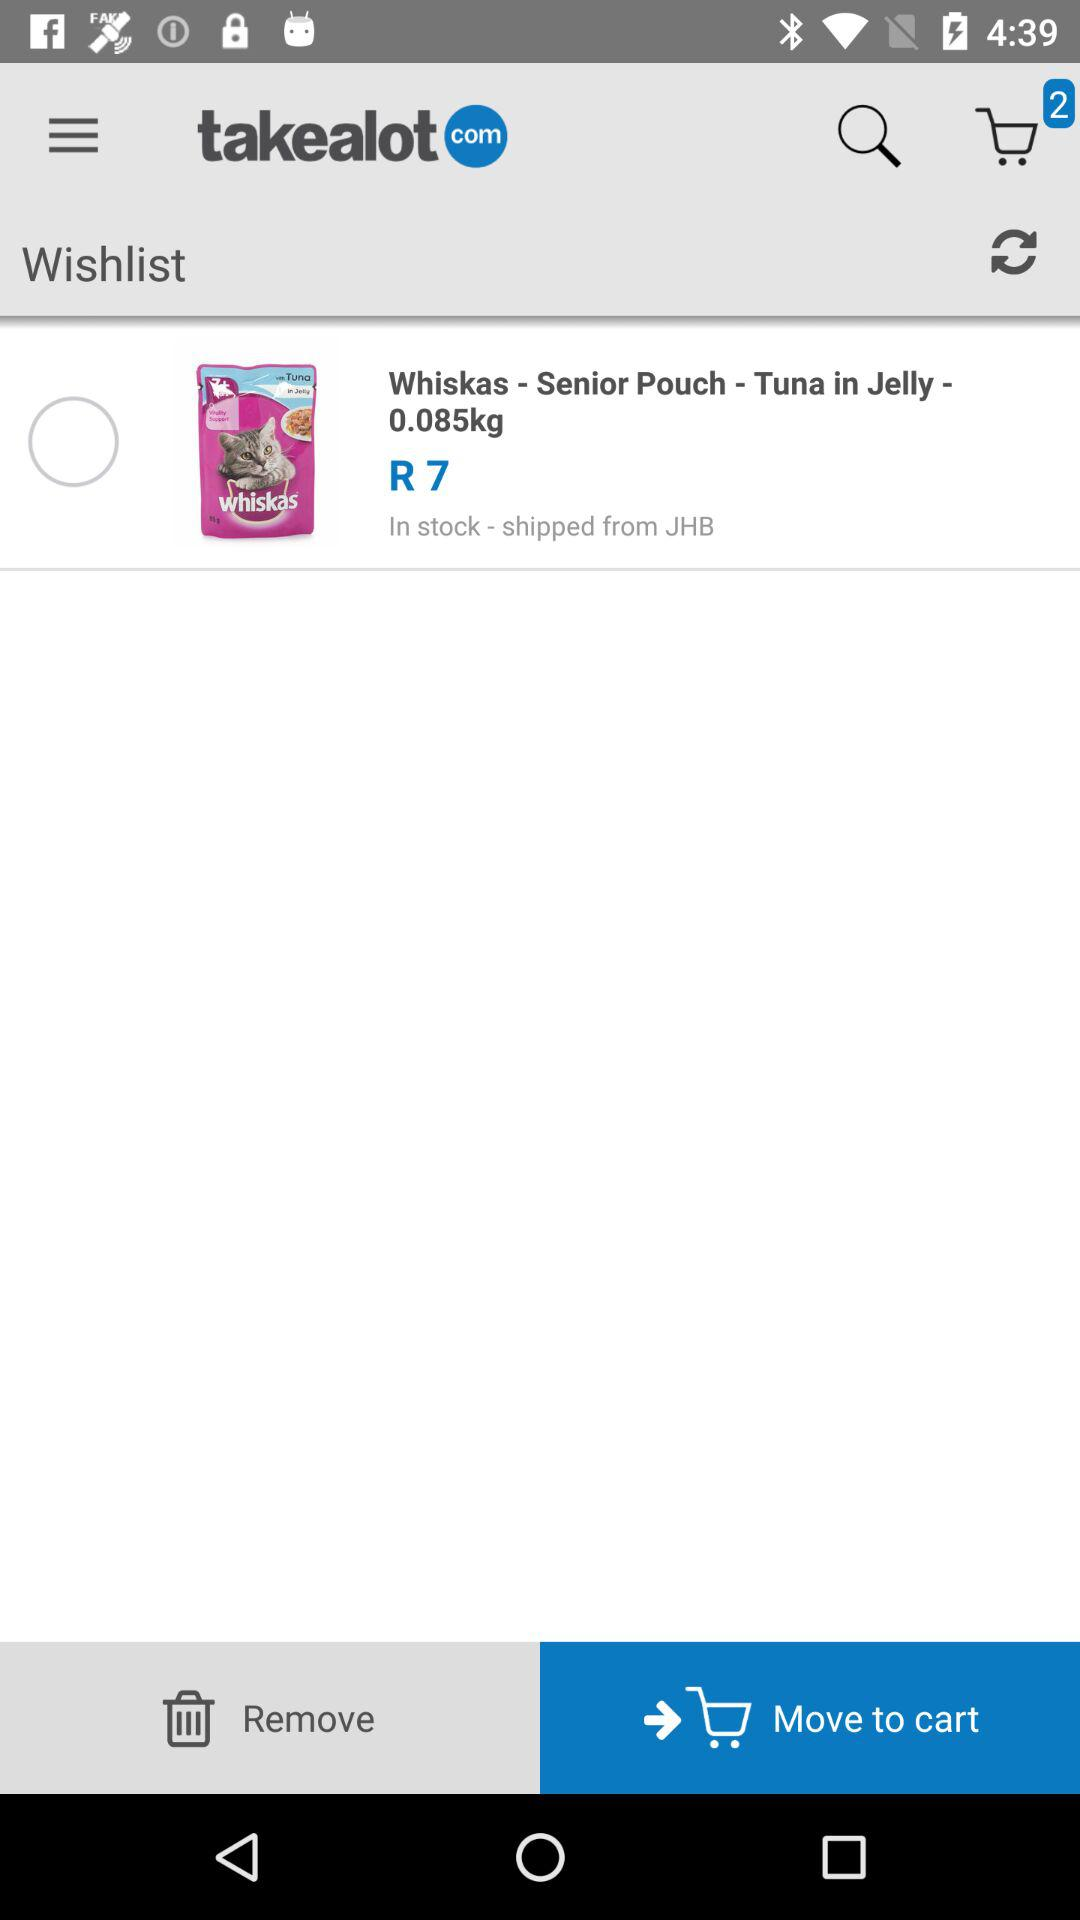How many items are in the shopping cart?
Answer the question using a single word or phrase. 2 